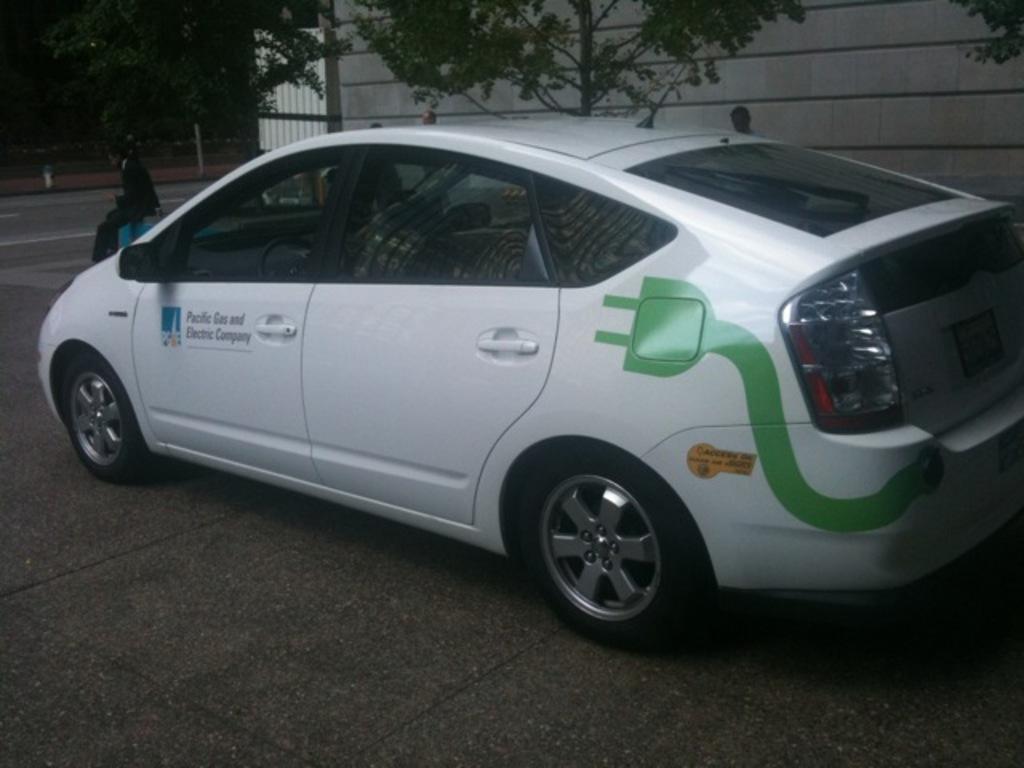How would you summarize this image in a sentence or two? In this picture we can see a car, people on the road and in the background we can see a building, trees, metal pole and some objects. 